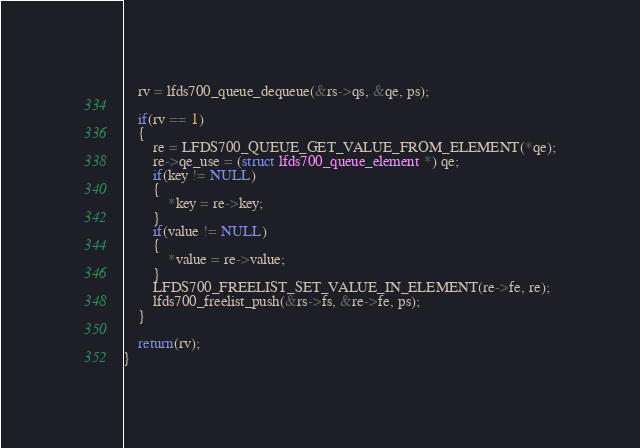Convert code to text. <code><loc_0><loc_0><loc_500><loc_500><_C_>    rv = lfds700_queue_dequeue(&rs->qs, &qe, ps);

    if(rv == 1)
    {
        re = LFDS700_QUEUE_GET_VALUE_FROM_ELEMENT(*qe);
        re->qe_use = (struct lfds700_queue_element *) qe;
        if(key != NULL)
        {
            *key = re->key;
        }
        if(value != NULL)
        {
            *value = re->value;
        }
        LFDS700_FREELIST_SET_VALUE_IN_ELEMENT(re->fe, re);
        lfds700_freelist_push(&rs->fs, &re->fe, ps);
    }

    return(rv);
}

</code> 